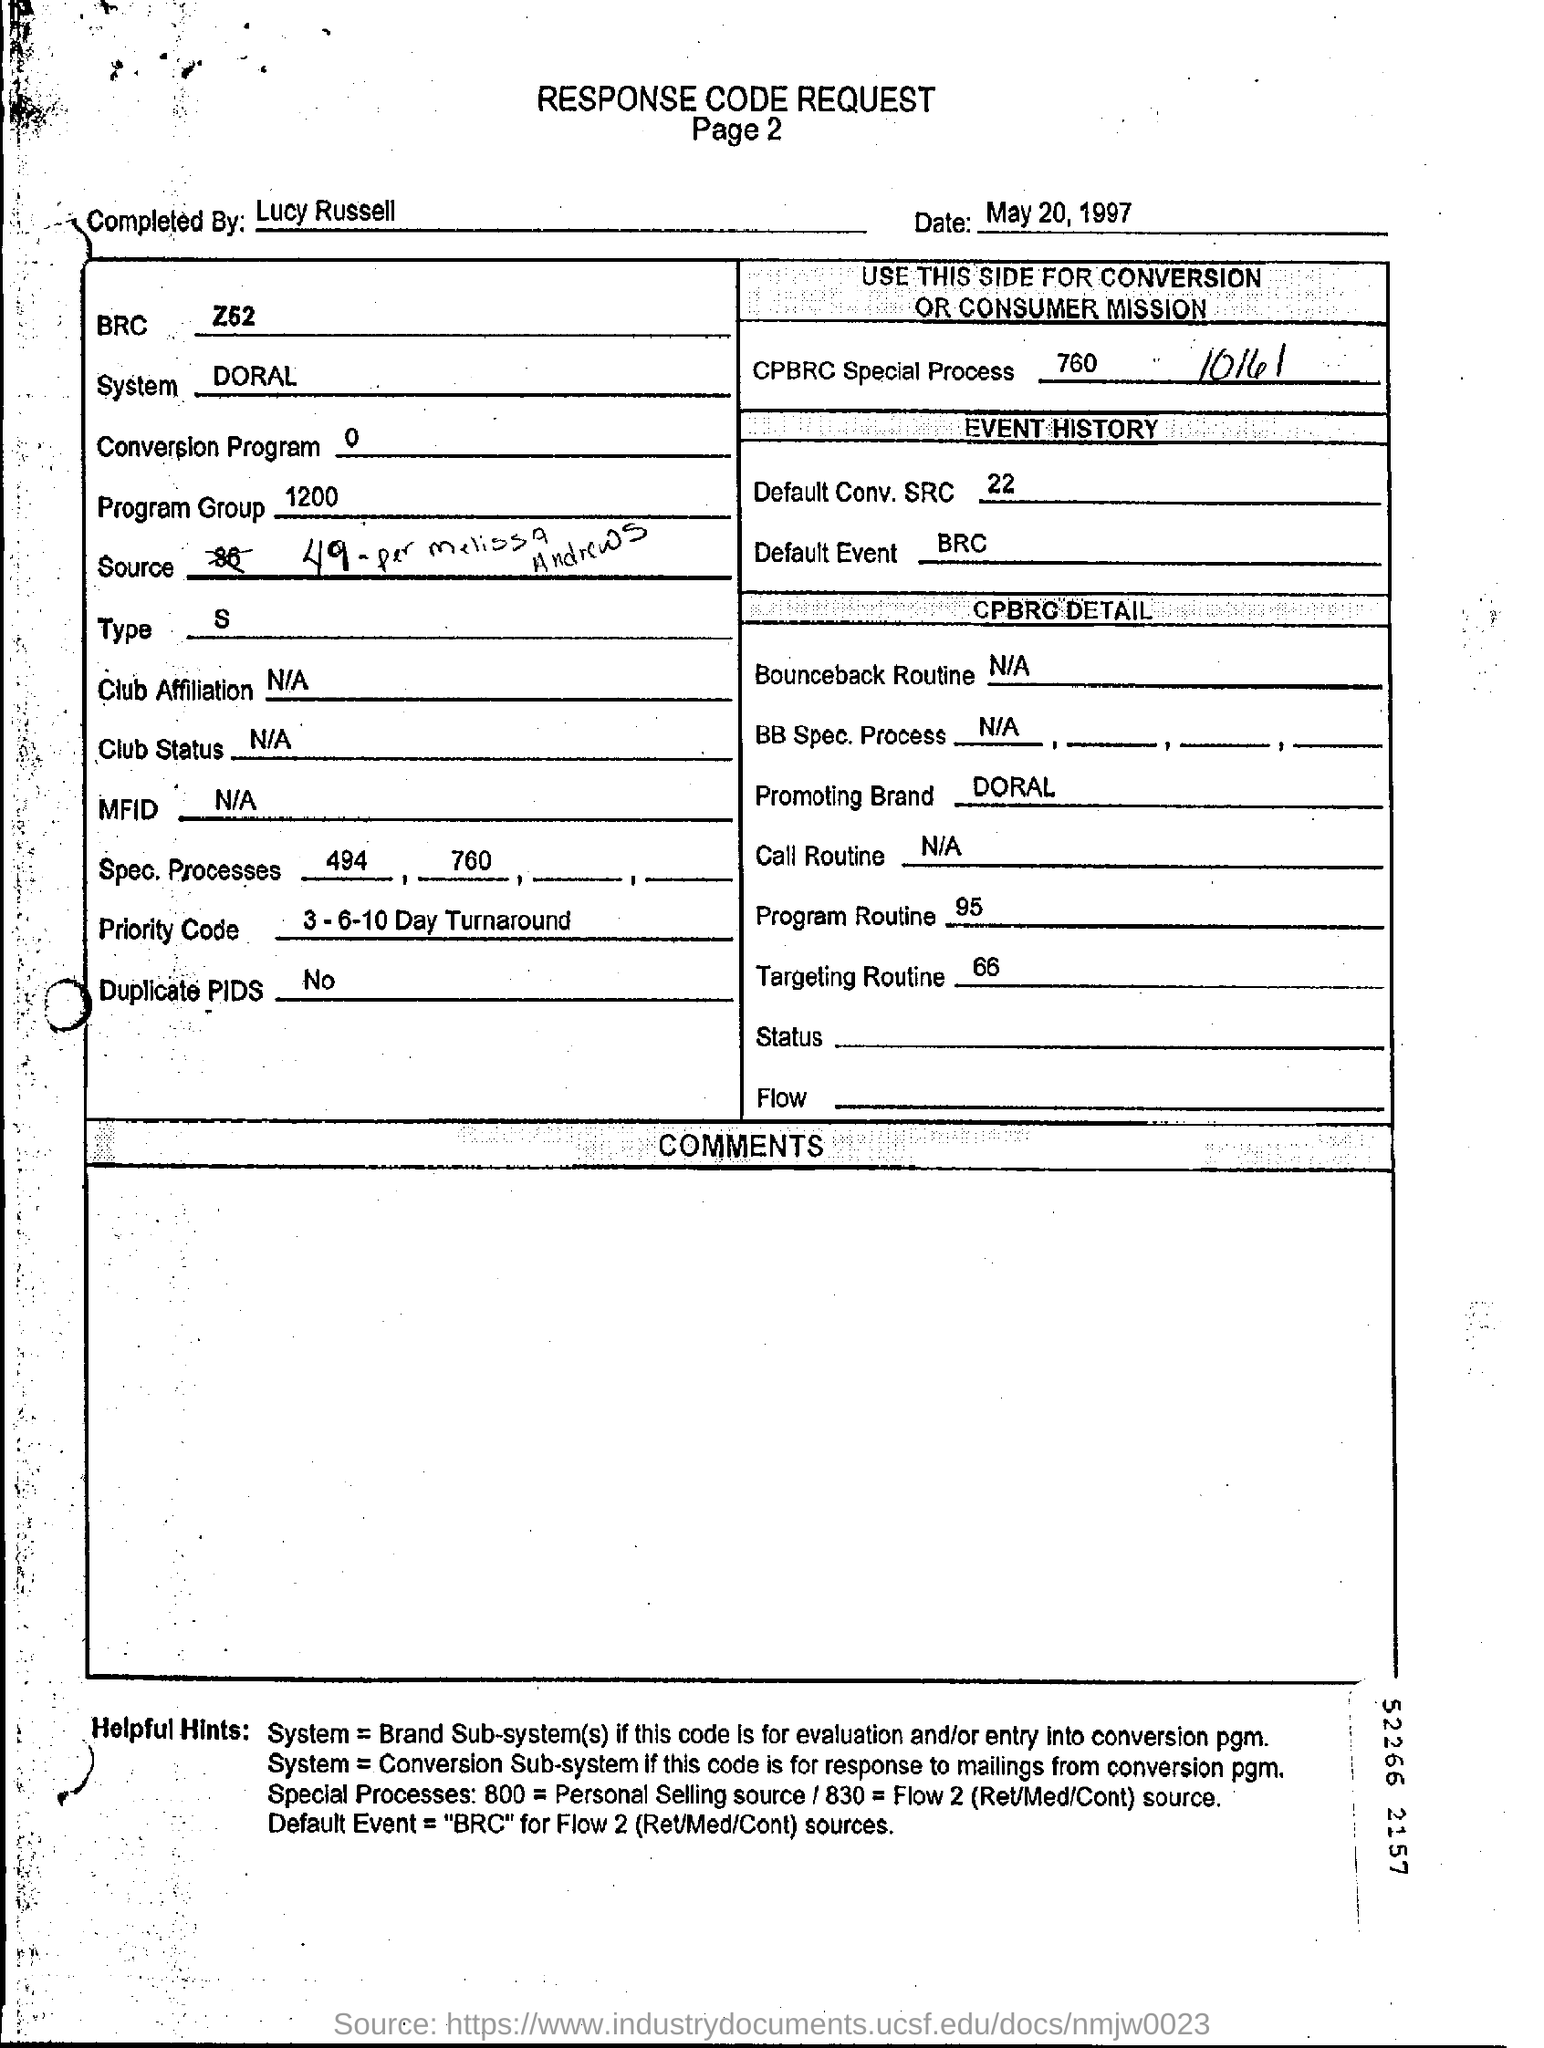Outline some significant characteristics in this image. The response code request was completed by Lucy Russell. The program group is a collection of programs that are associated with each other. It is designated as 1200. There are no duplicate PIDs. 